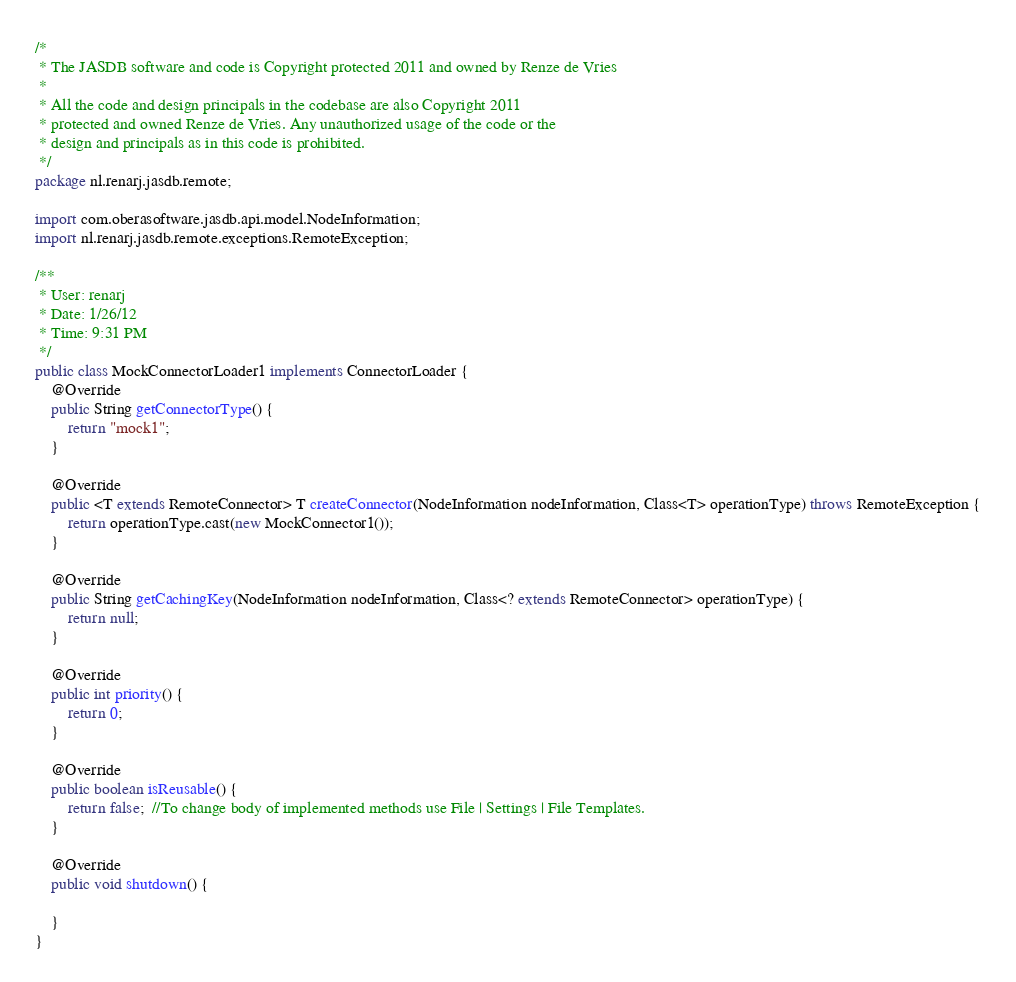<code> <loc_0><loc_0><loc_500><loc_500><_Java_>/*
 * The JASDB software and code is Copyright protected 2011 and owned by Renze de Vries
 * 
 * All the code and design principals in the codebase are also Copyright 2011 
 * protected and owned Renze de Vries. Any unauthorized usage of the code or the 
 * design and principals as in this code is prohibited.
 */
package nl.renarj.jasdb.remote;

import com.oberasoftware.jasdb.api.model.NodeInformation;
import nl.renarj.jasdb.remote.exceptions.RemoteException;

/**
 * User: renarj
 * Date: 1/26/12
 * Time: 9:31 PM
 */
public class MockConnectorLoader1 implements ConnectorLoader {
    @Override
    public String getConnectorType() {
        return "mock1";
    }

    @Override
    public <T extends RemoteConnector> T createConnector(NodeInformation nodeInformation, Class<T> operationType) throws RemoteException {
        return operationType.cast(new MockConnector1());
    }

    @Override
    public String getCachingKey(NodeInformation nodeInformation, Class<? extends RemoteConnector> operationType) {
        return null;
    }

    @Override
    public int priority() {
        return 0;
    }

    @Override
    public boolean isReusable() {
        return false;  //To change body of implemented methods use File | Settings | File Templates.
    }

    @Override
    public void shutdown() {

    }
}
</code> 